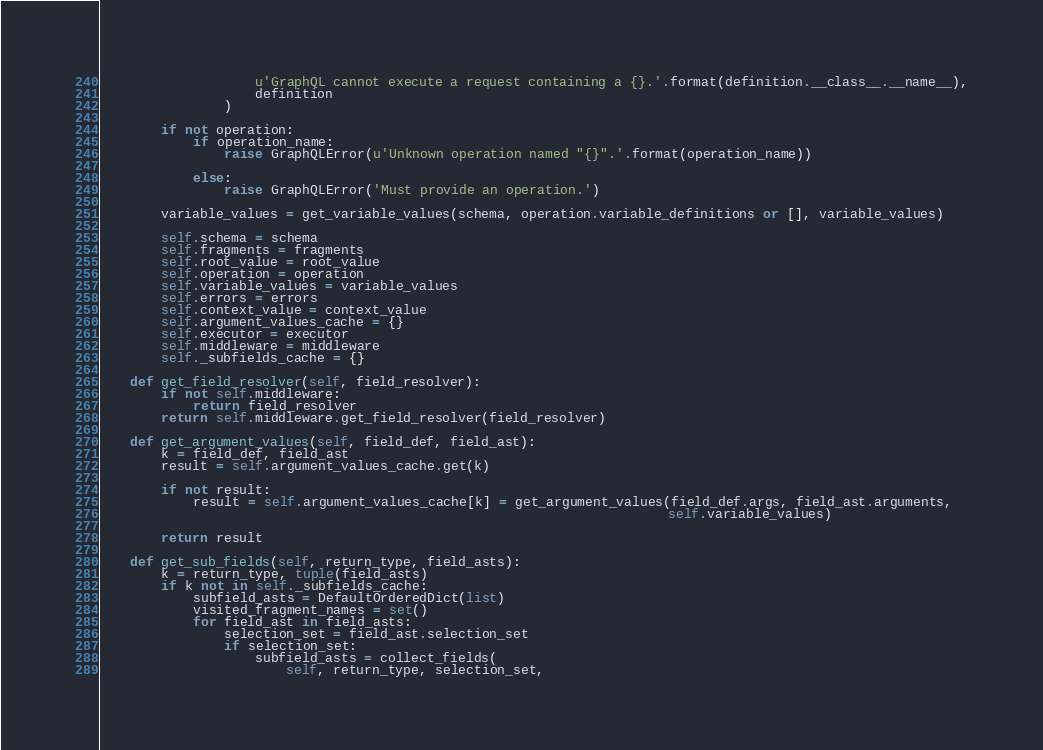<code> <loc_0><loc_0><loc_500><loc_500><_Python_>                    u'GraphQL cannot execute a request containing a {}.'.format(definition.__class__.__name__),
                    definition
                )

        if not operation:
            if operation_name:
                raise GraphQLError(u'Unknown operation named "{}".'.format(operation_name))

            else:
                raise GraphQLError('Must provide an operation.')

        variable_values = get_variable_values(schema, operation.variable_definitions or [], variable_values)

        self.schema = schema
        self.fragments = fragments
        self.root_value = root_value
        self.operation = operation
        self.variable_values = variable_values
        self.errors = errors
        self.context_value = context_value
        self.argument_values_cache = {}
        self.executor = executor
        self.middleware = middleware
        self._subfields_cache = {}

    def get_field_resolver(self, field_resolver):
        if not self.middleware:
            return field_resolver
        return self.middleware.get_field_resolver(field_resolver)

    def get_argument_values(self, field_def, field_ast):
        k = field_def, field_ast
        result = self.argument_values_cache.get(k)

        if not result:
            result = self.argument_values_cache[k] = get_argument_values(field_def.args, field_ast.arguments,
                                                                         self.variable_values)

        return result

    def get_sub_fields(self, return_type, field_asts):
        k = return_type, tuple(field_asts)
        if k not in self._subfields_cache:
            subfield_asts = DefaultOrderedDict(list)
            visited_fragment_names = set()
            for field_ast in field_asts:
                selection_set = field_ast.selection_set
                if selection_set:
                    subfield_asts = collect_fields(
                        self, return_type, selection_set,</code> 